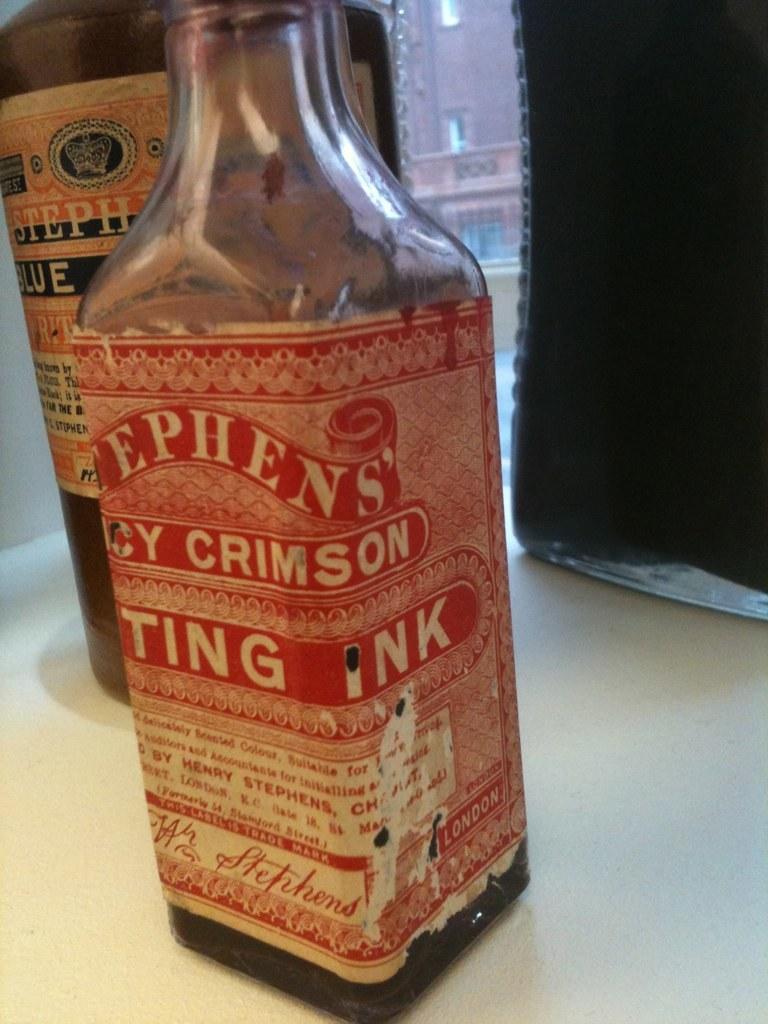What is in the bottle?
Provide a succinct answer. Ink. 